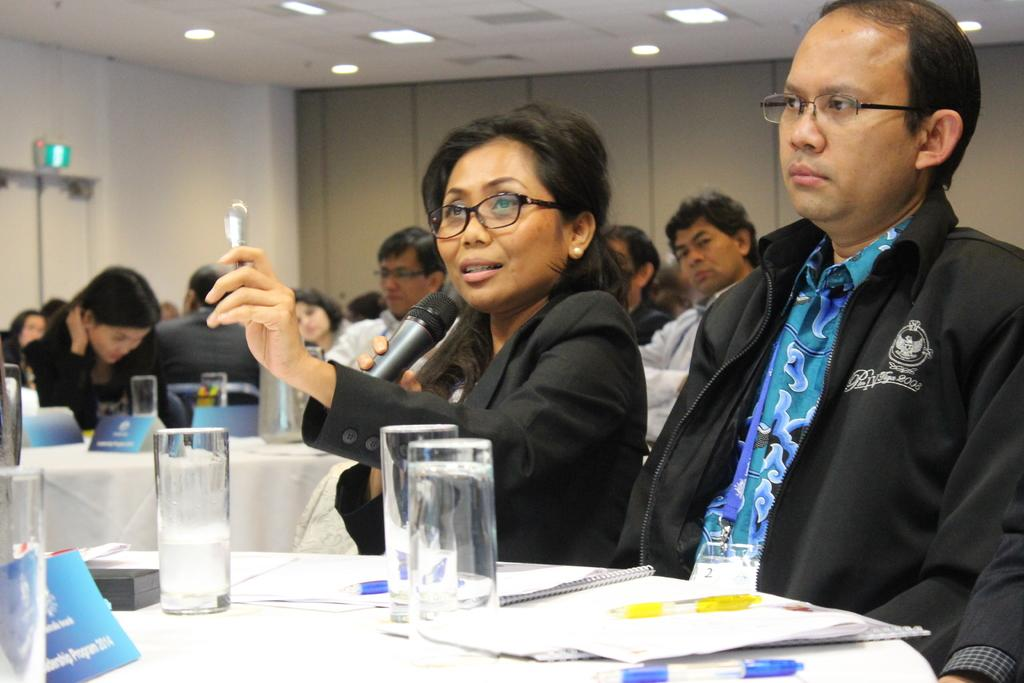What is the woman in the image holding in one hand? The woman is holding a microphone in one hand. What is the woman holding in her other hand? The woman is holding a spoon in her other hand. What can be seen near the people sitting on chairs in the image? There are tables near the people sitting on chairs. What objects are on the tables? There are glasses on the tables. What type of beam is supporting the ceiling in the image? There is no beam supporting the ceiling in the image; it is not mentioned in the provided facts. 